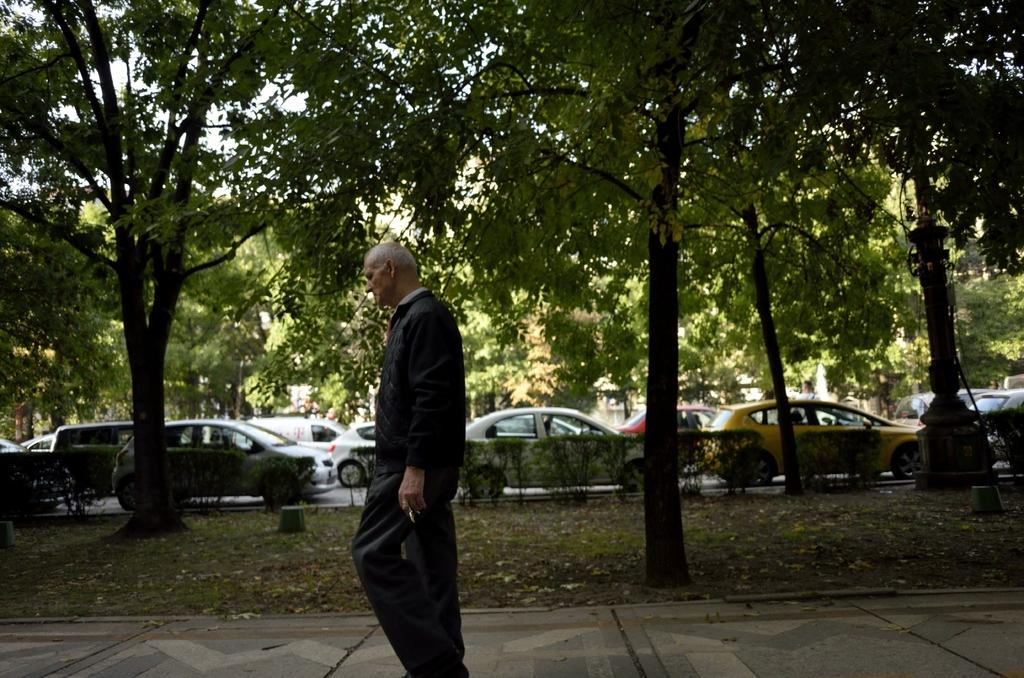What is the person in the image doing? There is a person walking on a path in the image. What type of vegetation is present in the grassland? There are trees on the grassland in the image, and it also has plants. What can be seen in the background of the image? There are vehicles on the road and trees in the background of the image. What type of stick is the goat holding in the image? There is no goat or stick present in the image. 